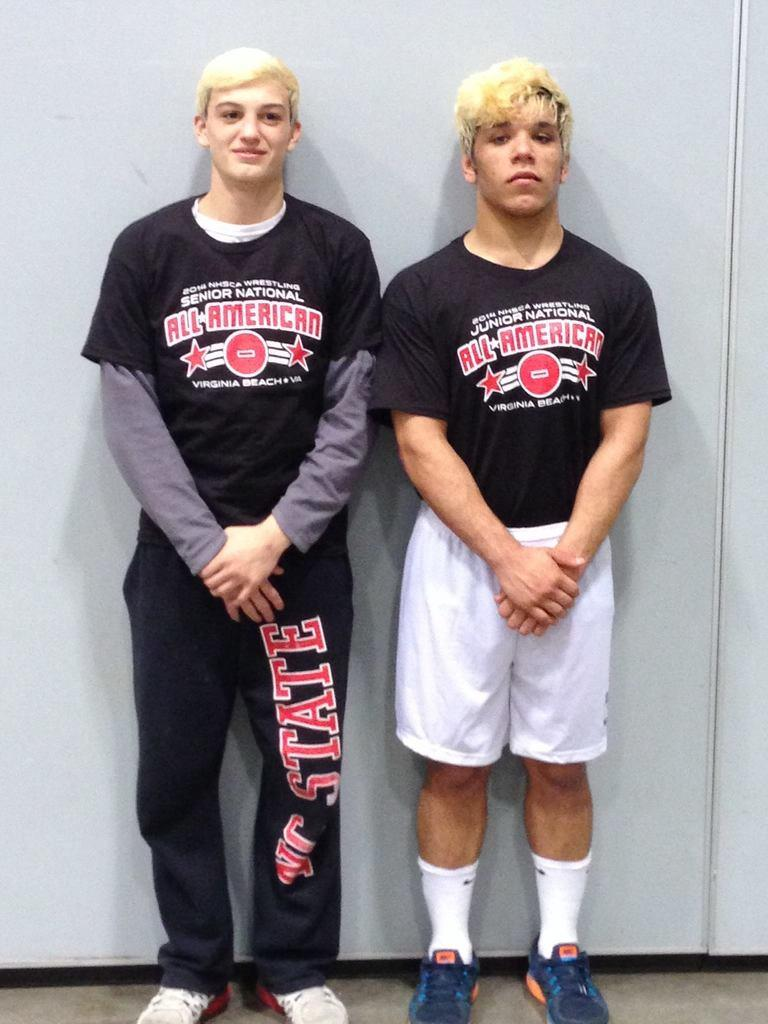<image>
Render a clear and concise summary of the photo. 2 men are wearing shirts that say all american. 